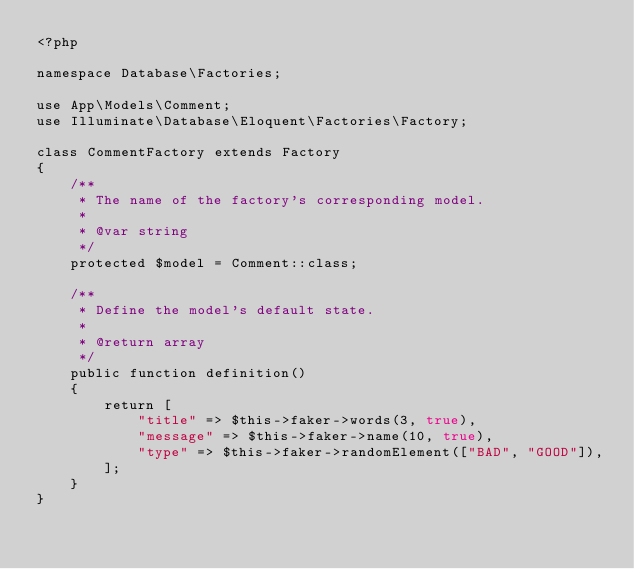Convert code to text. <code><loc_0><loc_0><loc_500><loc_500><_PHP_><?php

namespace Database\Factories;

use App\Models\Comment;
use Illuminate\Database\Eloquent\Factories\Factory;

class CommentFactory extends Factory
{
    /**
     * The name of the factory's corresponding model.
     *
     * @var string
     */
    protected $model = Comment::class;

    /**
     * Define the model's default state.
     *
     * @return array
     */
    public function definition()
    {
        return [
            "title" => $this->faker->words(3, true),
            "message" => $this->faker->name(10, true),
            "type" => $this->faker->randomElement(["BAD", "GOOD"]),
        ];
    }
}
</code> 